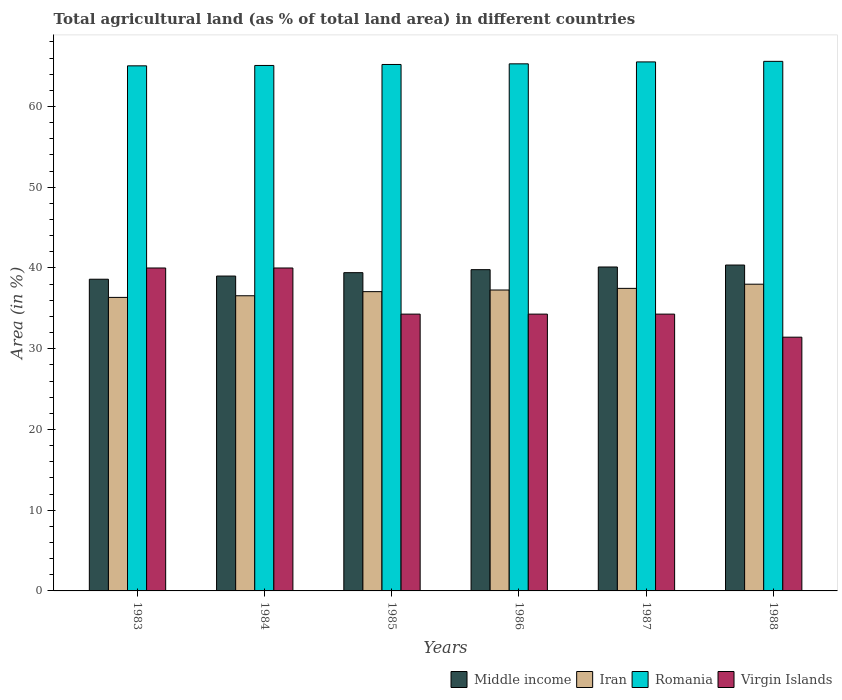How many different coloured bars are there?
Provide a succinct answer. 4. How many groups of bars are there?
Offer a terse response. 6. Are the number of bars per tick equal to the number of legend labels?
Provide a short and direct response. Yes. How many bars are there on the 3rd tick from the left?
Offer a terse response. 4. What is the percentage of agricultural land in Middle income in 1988?
Keep it short and to the point. 40.36. Across all years, what is the minimum percentage of agricultural land in Middle income?
Make the answer very short. 38.61. What is the total percentage of agricultural land in Romania in the graph?
Your response must be concise. 391.74. What is the difference between the percentage of agricultural land in Middle income in 1985 and that in 1986?
Your answer should be very brief. -0.37. What is the difference between the percentage of agricultural land in Iran in 1987 and the percentage of agricultural land in Virgin Islands in 1983?
Keep it short and to the point. -2.52. What is the average percentage of agricultural land in Middle income per year?
Provide a succinct answer. 39.55. In the year 1984, what is the difference between the percentage of agricultural land in Virgin Islands and percentage of agricultural land in Iran?
Provide a short and direct response. 3.44. What is the ratio of the percentage of agricultural land in Middle income in 1985 to that in 1986?
Your answer should be compact. 0.99. Is the difference between the percentage of agricultural land in Virgin Islands in 1987 and 1988 greater than the difference between the percentage of agricultural land in Iran in 1987 and 1988?
Provide a short and direct response. Yes. What is the difference between the highest and the second highest percentage of agricultural land in Middle income?
Provide a short and direct response. 0.24. What is the difference between the highest and the lowest percentage of agricultural land in Romania?
Make the answer very short. 0.56. In how many years, is the percentage of agricultural land in Iran greater than the average percentage of agricultural land in Iran taken over all years?
Ensure brevity in your answer.  3. Is the sum of the percentage of agricultural land in Virgin Islands in 1985 and 1986 greater than the maximum percentage of agricultural land in Iran across all years?
Make the answer very short. Yes. Is it the case that in every year, the sum of the percentage of agricultural land in Virgin Islands and percentage of agricultural land in Romania is greater than the sum of percentage of agricultural land in Iran and percentage of agricultural land in Middle income?
Offer a very short reply. Yes. What does the 1st bar from the right in 1985 represents?
Your answer should be compact. Virgin Islands. How many bars are there?
Ensure brevity in your answer.  24. How many years are there in the graph?
Make the answer very short. 6. What is the difference between two consecutive major ticks on the Y-axis?
Keep it short and to the point. 10. Does the graph contain grids?
Offer a very short reply. No. What is the title of the graph?
Offer a terse response. Total agricultural land (as % of total land area) in different countries. Does "Argentina" appear as one of the legend labels in the graph?
Your answer should be very brief. No. What is the label or title of the Y-axis?
Your answer should be compact. Area (in %). What is the Area (in %) in Middle income in 1983?
Provide a short and direct response. 38.61. What is the Area (in %) in Iran in 1983?
Your response must be concise. 36.36. What is the Area (in %) in Romania in 1983?
Keep it short and to the point. 65.04. What is the Area (in %) of Virgin Islands in 1983?
Offer a very short reply. 40. What is the Area (in %) of Middle income in 1984?
Give a very brief answer. 39. What is the Area (in %) of Iran in 1984?
Give a very brief answer. 36.56. What is the Area (in %) of Romania in 1984?
Provide a short and direct response. 65.09. What is the Area (in %) of Virgin Islands in 1984?
Provide a short and direct response. 40. What is the Area (in %) of Middle income in 1985?
Your answer should be compact. 39.42. What is the Area (in %) in Iran in 1985?
Provide a short and direct response. 37.07. What is the Area (in %) in Romania in 1985?
Keep it short and to the point. 65.21. What is the Area (in %) of Virgin Islands in 1985?
Keep it short and to the point. 34.29. What is the Area (in %) in Middle income in 1986?
Provide a short and direct response. 39.79. What is the Area (in %) in Iran in 1986?
Make the answer very short. 37.27. What is the Area (in %) of Romania in 1986?
Offer a terse response. 65.29. What is the Area (in %) of Virgin Islands in 1986?
Your answer should be very brief. 34.29. What is the Area (in %) of Middle income in 1987?
Provide a succinct answer. 40.12. What is the Area (in %) of Iran in 1987?
Offer a very short reply. 37.48. What is the Area (in %) in Romania in 1987?
Provide a succinct answer. 65.52. What is the Area (in %) in Virgin Islands in 1987?
Ensure brevity in your answer.  34.29. What is the Area (in %) of Middle income in 1988?
Keep it short and to the point. 40.36. What is the Area (in %) of Iran in 1988?
Your response must be concise. 37.99. What is the Area (in %) in Romania in 1988?
Your answer should be compact. 65.59. What is the Area (in %) in Virgin Islands in 1988?
Your answer should be very brief. 31.43. Across all years, what is the maximum Area (in %) in Middle income?
Make the answer very short. 40.36. Across all years, what is the maximum Area (in %) in Iran?
Offer a very short reply. 37.99. Across all years, what is the maximum Area (in %) in Romania?
Provide a succinct answer. 65.59. Across all years, what is the maximum Area (in %) in Virgin Islands?
Keep it short and to the point. 40. Across all years, what is the minimum Area (in %) of Middle income?
Offer a very short reply. 38.61. Across all years, what is the minimum Area (in %) in Iran?
Provide a succinct answer. 36.36. Across all years, what is the minimum Area (in %) of Romania?
Your answer should be compact. 65.04. Across all years, what is the minimum Area (in %) of Virgin Islands?
Keep it short and to the point. 31.43. What is the total Area (in %) of Middle income in the graph?
Offer a terse response. 237.31. What is the total Area (in %) of Iran in the graph?
Give a very brief answer. 222.73. What is the total Area (in %) in Romania in the graph?
Provide a short and direct response. 391.74. What is the total Area (in %) in Virgin Islands in the graph?
Provide a short and direct response. 214.29. What is the difference between the Area (in %) in Middle income in 1983 and that in 1984?
Keep it short and to the point. -0.39. What is the difference between the Area (in %) of Iran in 1983 and that in 1984?
Keep it short and to the point. -0.2. What is the difference between the Area (in %) in Romania in 1983 and that in 1984?
Give a very brief answer. -0.05. What is the difference between the Area (in %) of Virgin Islands in 1983 and that in 1984?
Give a very brief answer. 0. What is the difference between the Area (in %) in Middle income in 1983 and that in 1985?
Your answer should be compact. -0.81. What is the difference between the Area (in %) of Iran in 1983 and that in 1985?
Your answer should be compact. -0.71. What is the difference between the Area (in %) of Romania in 1983 and that in 1985?
Make the answer very short. -0.17. What is the difference between the Area (in %) of Virgin Islands in 1983 and that in 1985?
Ensure brevity in your answer.  5.71. What is the difference between the Area (in %) of Middle income in 1983 and that in 1986?
Your answer should be very brief. -1.18. What is the difference between the Area (in %) of Iran in 1983 and that in 1986?
Provide a short and direct response. -0.91. What is the difference between the Area (in %) in Romania in 1983 and that in 1986?
Provide a short and direct response. -0.25. What is the difference between the Area (in %) in Virgin Islands in 1983 and that in 1986?
Your answer should be compact. 5.71. What is the difference between the Area (in %) in Middle income in 1983 and that in 1987?
Your answer should be compact. -1.51. What is the difference between the Area (in %) of Iran in 1983 and that in 1987?
Make the answer very short. -1.12. What is the difference between the Area (in %) of Romania in 1983 and that in 1987?
Offer a terse response. -0.49. What is the difference between the Area (in %) of Virgin Islands in 1983 and that in 1987?
Offer a very short reply. 5.71. What is the difference between the Area (in %) in Middle income in 1983 and that in 1988?
Offer a terse response. -1.76. What is the difference between the Area (in %) of Iran in 1983 and that in 1988?
Ensure brevity in your answer.  -1.63. What is the difference between the Area (in %) of Romania in 1983 and that in 1988?
Ensure brevity in your answer.  -0.56. What is the difference between the Area (in %) in Virgin Islands in 1983 and that in 1988?
Make the answer very short. 8.57. What is the difference between the Area (in %) in Middle income in 1984 and that in 1985?
Your answer should be very brief. -0.42. What is the difference between the Area (in %) in Iran in 1984 and that in 1985?
Ensure brevity in your answer.  -0.51. What is the difference between the Area (in %) in Romania in 1984 and that in 1985?
Your response must be concise. -0.12. What is the difference between the Area (in %) in Virgin Islands in 1984 and that in 1985?
Ensure brevity in your answer.  5.71. What is the difference between the Area (in %) in Middle income in 1984 and that in 1986?
Provide a short and direct response. -0.79. What is the difference between the Area (in %) of Iran in 1984 and that in 1986?
Give a very brief answer. -0.71. What is the difference between the Area (in %) of Romania in 1984 and that in 1986?
Keep it short and to the point. -0.2. What is the difference between the Area (in %) of Virgin Islands in 1984 and that in 1986?
Ensure brevity in your answer.  5.71. What is the difference between the Area (in %) of Middle income in 1984 and that in 1987?
Your answer should be compact. -1.12. What is the difference between the Area (in %) in Iran in 1984 and that in 1987?
Your answer should be very brief. -0.91. What is the difference between the Area (in %) of Romania in 1984 and that in 1987?
Your response must be concise. -0.44. What is the difference between the Area (in %) of Virgin Islands in 1984 and that in 1987?
Your response must be concise. 5.71. What is the difference between the Area (in %) in Middle income in 1984 and that in 1988?
Offer a very short reply. -1.36. What is the difference between the Area (in %) of Iran in 1984 and that in 1988?
Offer a terse response. -1.43. What is the difference between the Area (in %) of Romania in 1984 and that in 1988?
Your answer should be compact. -0.51. What is the difference between the Area (in %) of Virgin Islands in 1984 and that in 1988?
Keep it short and to the point. 8.57. What is the difference between the Area (in %) of Middle income in 1985 and that in 1986?
Offer a very short reply. -0.37. What is the difference between the Area (in %) in Iran in 1985 and that in 1986?
Your answer should be compact. -0.2. What is the difference between the Area (in %) in Romania in 1985 and that in 1986?
Your response must be concise. -0.08. What is the difference between the Area (in %) in Middle income in 1985 and that in 1987?
Make the answer very short. -0.7. What is the difference between the Area (in %) of Iran in 1985 and that in 1987?
Offer a terse response. -0.41. What is the difference between the Area (in %) of Romania in 1985 and that in 1987?
Your answer should be compact. -0.32. What is the difference between the Area (in %) of Virgin Islands in 1985 and that in 1987?
Provide a succinct answer. 0. What is the difference between the Area (in %) in Middle income in 1985 and that in 1988?
Offer a very short reply. -0.94. What is the difference between the Area (in %) in Iran in 1985 and that in 1988?
Keep it short and to the point. -0.92. What is the difference between the Area (in %) in Romania in 1985 and that in 1988?
Your answer should be compact. -0.39. What is the difference between the Area (in %) of Virgin Islands in 1985 and that in 1988?
Provide a short and direct response. 2.86. What is the difference between the Area (in %) in Middle income in 1986 and that in 1987?
Your answer should be compact. -0.33. What is the difference between the Area (in %) of Iran in 1986 and that in 1987?
Your response must be concise. -0.2. What is the difference between the Area (in %) in Romania in 1986 and that in 1987?
Your response must be concise. -0.24. What is the difference between the Area (in %) of Middle income in 1986 and that in 1988?
Give a very brief answer. -0.57. What is the difference between the Area (in %) in Iran in 1986 and that in 1988?
Give a very brief answer. -0.72. What is the difference between the Area (in %) of Romania in 1986 and that in 1988?
Offer a terse response. -0.31. What is the difference between the Area (in %) of Virgin Islands in 1986 and that in 1988?
Your answer should be very brief. 2.86. What is the difference between the Area (in %) of Middle income in 1987 and that in 1988?
Your response must be concise. -0.24. What is the difference between the Area (in %) in Iran in 1987 and that in 1988?
Keep it short and to the point. -0.52. What is the difference between the Area (in %) of Romania in 1987 and that in 1988?
Offer a terse response. -0.07. What is the difference between the Area (in %) of Virgin Islands in 1987 and that in 1988?
Offer a very short reply. 2.86. What is the difference between the Area (in %) in Middle income in 1983 and the Area (in %) in Iran in 1984?
Your answer should be very brief. 2.05. What is the difference between the Area (in %) of Middle income in 1983 and the Area (in %) of Romania in 1984?
Offer a very short reply. -26.48. What is the difference between the Area (in %) of Middle income in 1983 and the Area (in %) of Virgin Islands in 1984?
Your answer should be compact. -1.39. What is the difference between the Area (in %) in Iran in 1983 and the Area (in %) in Romania in 1984?
Your response must be concise. -28.73. What is the difference between the Area (in %) of Iran in 1983 and the Area (in %) of Virgin Islands in 1984?
Your answer should be very brief. -3.64. What is the difference between the Area (in %) in Romania in 1983 and the Area (in %) in Virgin Islands in 1984?
Provide a short and direct response. 25.04. What is the difference between the Area (in %) of Middle income in 1983 and the Area (in %) of Iran in 1985?
Your answer should be compact. 1.54. What is the difference between the Area (in %) of Middle income in 1983 and the Area (in %) of Romania in 1985?
Your answer should be compact. -26.6. What is the difference between the Area (in %) of Middle income in 1983 and the Area (in %) of Virgin Islands in 1985?
Your answer should be very brief. 4.32. What is the difference between the Area (in %) in Iran in 1983 and the Area (in %) in Romania in 1985?
Give a very brief answer. -28.85. What is the difference between the Area (in %) of Iran in 1983 and the Area (in %) of Virgin Islands in 1985?
Make the answer very short. 2.07. What is the difference between the Area (in %) in Romania in 1983 and the Area (in %) in Virgin Islands in 1985?
Give a very brief answer. 30.75. What is the difference between the Area (in %) in Middle income in 1983 and the Area (in %) in Iran in 1986?
Your response must be concise. 1.34. What is the difference between the Area (in %) in Middle income in 1983 and the Area (in %) in Romania in 1986?
Your answer should be very brief. -26.68. What is the difference between the Area (in %) of Middle income in 1983 and the Area (in %) of Virgin Islands in 1986?
Make the answer very short. 4.32. What is the difference between the Area (in %) in Iran in 1983 and the Area (in %) in Romania in 1986?
Your response must be concise. -28.93. What is the difference between the Area (in %) in Iran in 1983 and the Area (in %) in Virgin Islands in 1986?
Your answer should be compact. 2.07. What is the difference between the Area (in %) of Romania in 1983 and the Area (in %) of Virgin Islands in 1986?
Your response must be concise. 30.75. What is the difference between the Area (in %) of Middle income in 1983 and the Area (in %) of Iran in 1987?
Provide a succinct answer. 1.13. What is the difference between the Area (in %) of Middle income in 1983 and the Area (in %) of Romania in 1987?
Your answer should be very brief. -26.92. What is the difference between the Area (in %) of Middle income in 1983 and the Area (in %) of Virgin Islands in 1987?
Your response must be concise. 4.32. What is the difference between the Area (in %) in Iran in 1983 and the Area (in %) in Romania in 1987?
Provide a short and direct response. -29.17. What is the difference between the Area (in %) of Iran in 1983 and the Area (in %) of Virgin Islands in 1987?
Make the answer very short. 2.07. What is the difference between the Area (in %) of Romania in 1983 and the Area (in %) of Virgin Islands in 1987?
Offer a terse response. 30.75. What is the difference between the Area (in %) in Middle income in 1983 and the Area (in %) in Iran in 1988?
Ensure brevity in your answer.  0.62. What is the difference between the Area (in %) of Middle income in 1983 and the Area (in %) of Romania in 1988?
Your answer should be compact. -26.99. What is the difference between the Area (in %) in Middle income in 1983 and the Area (in %) in Virgin Islands in 1988?
Your answer should be very brief. 7.18. What is the difference between the Area (in %) in Iran in 1983 and the Area (in %) in Romania in 1988?
Provide a short and direct response. -29.24. What is the difference between the Area (in %) in Iran in 1983 and the Area (in %) in Virgin Islands in 1988?
Keep it short and to the point. 4.93. What is the difference between the Area (in %) in Romania in 1983 and the Area (in %) in Virgin Islands in 1988?
Keep it short and to the point. 33.61. What is the difference between the Area (in %) in Middle income in 1984 and the Area (in %) in Iran in 1985?
Provide a succinct answer. 1.93. What is the difference between the Area (in %) in Middle income in 1984 and the Area (in %) in Romania in 1985?
Provide a short and direct response. -26.21. What is the difference between the Area (in %) of Middle income in 1984 and the Area (in %) of Virgin Islands in 1985?
Your answer should be very brief. 4.71. What is the difference between the Area (in %) of Iran in 1984 and the Area (in %) of Romania in 1985?
Your answer should be compact. -28.65. What is the difference between the Area (in %) in Iran in 1984 and the Area (in %) in Virgin Islands in 1985?
Your response must be concise. 2.27. What is the difference between the Area (in %) of Romania in 1984 and the Area (in %) of Virgin Islands in 1985?
Give a very brief answer. 30.8. What is the difference between the Area (in %) of Middle income in 1984 and the Area (in %) of Iran in 1986?
Give a very brief answer. 1.73. What is the difference between the Area (in %) in Middle income in 1984 and the Area (in %) in Romania in 1986?
Your response must be concise. -26.29. What is the difference between the Area (in %) of Middle income in 1984 and the Area (in %) of Virgin Islands in 1986?
Keep it short and to the point. 4.71. What is the difference between the Area (in %) of Iran in 1984 and the Area (in %) of Romania in 1986?
Keep it short and to the point. -28.73. What is the difference between the Area (in %) of Iran in 1984 and the Area (in %) of Virgin Islands in 1986?
Provide a succinct answer. 2.27. What is the difference between the Area (in %) of Romania in 1984 and the Area (in %) of Virgin Islands in 1986?
Provide a succinct answer. 30.8. What is the difference between the Area (in %) in Middle income in 1984 and the Area (in %) in Iran in 1987?
Make the answer very short. 1.52. What is the difference between the Area (in %) of Middle income in 1984 and the Area (in %) of Romania in 1987?
Give a very brief answer. -26.53. What is the difference between the Area (in %) in Middle income in 1984 and the Area (in %) in Virgin Islands in 1987?
Provide a succinct answer. 4.71. What is the difference between the Area (in %) in Iran in 1984 and the Area (in %) in Romania in 1987?
Make the answer very short. -28.96. What is the difference between the Area (in %) in Iran in 1984 and the Area (in %) in Virgin Islands in 1987?
Ensure brevity in your answer.  2.27. What is the difference between the Area (in %) in Romania in 1984 and the Area (in %) in Virgin Islands in 1987?
Offer a terse response. 30.8. What is the difference between the Area (in %) of Middle income in 1984 and the Area (in %) of Iran in 1988?
Ensure brevity in your answer.  1.01. What is the difference between the Area (in %) of Middle income in 1984 and the Area (in %) of Romania in 1988?
Your answer should be very brief. -26.59. What is the difference between the Area (in %) in Middle income in 1984 and the Area (in %) in Virgin Islands in 1988?
Your answer should be very brief. 7.57. What is the difference between the Area (in %) of Iran in 1984 and the Area (in %) of Romania in 1988?
Keep it short and to the point. -29.03. What is the difference between the Area (in %) of Iran in 1984 and the Area (in %) of Virgin Islands in 1988?
Your answer should be compact. 5.13. What is the difference between the Area (in %) in Romania in 1984 and the Area (in %) in Virgin Islands in 1988?
Make the answer very short. 33.66. What is the difference between the Area (in %) in Middle income in 1985 and the Area (in %) in Iran in 1986?
Make the answer very short. 2.15. What is the difference between the Area (in %) of Middle income in 1985 and the Area (in %) of Romania in 1986?
Ensure brevity in your answer.  -25.87. What is the difference between the Area (in %) of Middle income in 1985 and the Area (in %) of Virgin Islands in 1986?
Keep it short and to the point. 5.13. What is the difference between the Area (in %) in Iran in 1985 and the Area (in %) in Romania in 1986?
Your answer should be compact. -28.22. What is the difference between the Area (in %) in Iran in 1985 and the Area (in %) in Virgin Islands in 1986?
Your answer should be very brief. 2.78. What is the difference between the Area (in %) of Romania in 1985 and the Area (in %) of Virgin Islands in 1986?
Offer a very short reply. 30.92. What is the difference between the Area (in %) in Middle income in 1985 and the Area (in %) in Iran in 1987?
Offer a very short reply. 1.94. What is the difference between the Area (in %) in Middle income in 1985 and the Area (in %) in Romania in 1987?
Your answer should be very brief. -26.11. What is the difference between the Area (in %) of Middle income in 1985 and the Area (in %) of Virgin Islands in 1987?
Provide a short and direct response. 5.13. What is the difference between the Area (in %) in Iran in 1985 and the Area (in %) in Romania in 1987?
Your answer should be very brief. -28.46. What is the difference between the Area (in %) in Iran in 1985 and the Area (in %) in Virgin Islands in 1987?
Offer a very short reply. 2.78. What is the difference between the Area (in %) of Romania in 1985 and the Area (in %) of Virgin Islands in 1987?
Keep it short and to the point. 30.92. What is the difference between the Area (in %) of Middle income in 1985 and the Area (in %) of Iran in 1988?
Make the answer very short. 1.43. What is the difference between the Area (in %) in Middle income in 1985 and the Area (in %) in Romania in 1988?
Your answer should be compact. -26.17. What is the difference between the Area (in %) of Middle income in 1985 and the Area (in %) of Virgin Islands in 1988?
Your answer should be compact. 7.99. What is the difference between the Area (in %) in Iran in 1985 and the Area (in %) in Romania in 1988?
Offer a terse response. -28.52. What is the difference between the Area (in %) in Iran in 1985 and the Area (in %) in Virgin Islands in 1988?
Provide a short and direct response. 5.64. What is the difference between the Area (in %) of Romania in 1985 and the Area (in %) of Virgin Islands in 1988?
Your answer should be compact. 33.78. What is the difference between the Area (in %) in Middle income in 1986 and the Area (in %) in Iran in 1987?
Provide a succinct answer. 2.32. What is the difference between the Area (in %) in Middle income in 1986 and the Area (in %) in Romania in 1987?
Ensure brevity in your answer.  -25.73. What is the difference between the Area (in %) of Middle income in 1986 and the Area (in %) of Virgin Islands in 1987?
Offer a terse response. 5.51. What is the difference between the Area (in %) in Iran in 1986 and the Area (in %) in Romania in 1987?
Provide a short and direct response. -28.25. What is the difference between the Area (in %) of Iran in 1986 and the Area (in %) of Virgin Islands in 1987?
Provide a short and direct response. 2.99. What is the difference between the Area (in %) in Romania in 1986 and the Area (in %) in Virgin Islands in 1987?
Your response must be concise. 31. What is the difference between the Area (in %) of Middle income in 1986 and the Area (in %) of Iran in 1988?
Your response must be concise. 1.8. What is the difference between the Area (in %) in Middle income in 1986 and the Area (in %) in Romania in 1988?
Ensure brevity in your answer.  -25.8. What is the difference between the Area (in %) of Middle income in 1986 and the Area (in %) of Virgin Islands in 1988?
Give a very brief answer. 8.36. What is the difference between the Area (in %) of Iran in 1986 and the Area (in %) of Romania in 1988?
Your answer should be very brief. -28.32. What is the difference between the Area (in %) in Iran in 1986 and the Area (in %) in Virgin Islands in 1988?
Ensure brevity in your answer.  5.84. What is the difference between the Area (in %) of Romania in 1986 and the Area (in %) of Virgin Islands in 1988?
Offer a terse response. 33.86. What is the difference between the Area (in %) of Middle income in 1987 and the Area (in %) of Iran in 1988?
Offer a very short reply. 2.13. What is the difference between the Area (in %) of Middle income in 1987 and the Area (in %) of Romania in 1988?
Your answer should be compact. -25.47. What is the difference between the Area (in %) of Middle income in 1987 and the Area (in %) of Virgin Islands in 1988?
Ensure brevity in your answer.  8.69. What is the difference between the Area (in %) of Iran in 1987 and the Area (in %) of Romania in 1988?
Provide a succinct answer. -28.12. What is the difference between the Area (in %) in Iran in 1987 and the Area (in %) in Virgin Islands in 1988?
Your answer should be compact. 6.05. What is the difference between the Area (in %) in Romania in 1987 and the Area (in %) in Virgin Islands in 1988?
Offer a very short reply. 34.1. What is the average Area (in %) in Middle income per year?
Keep it short and to the point. 39.55. What is the average Area (in %) of Iran per year?
Make the answer very short. 37.12. What is the average Area (in %) of Romania per year?
Ensure brevity in your answer.  65.29. What is the average Area (in %) in Virgin Islands per year?
Provide a succinct answer. 35.71. In the year 1983, what is the difference between the Area (in %) in Middle income and Area (in %) in Iran?
Offer a very short reply. 2.25. In the year 1983, what is the difference between the Area (in %) in Middle income and Area (in %) in Romania?
Your answer should be compact. -26.43. In the year 1983, what is the difference between the Area (in %) of Middle income and Area (in %) of Virgin Islands?
Your response must be concise. -1.39. In the year 1983, what is the difference between the Area (in %) in Iran and Area (in %) in Romania?
Your answer should be compact. -28.68. In the year 1983, what is the difference between the Area (in %) in Iran and Area (in %) in Virgin Islands?
Ensure brevity in your answer.  -3.64. In the year 1983, what is the difference between the Area (in %) of Romania and Area (in %) of Virgin Islands?
Keep it short and to the point. 25.04. In the year 1984, what is the difference between the Area (in %) in Middle income and Area (in %) in Iran?
Provide a short and direct response. 2.44. In the year 1984, what is the difference between the Area (in %) of Middle income and Area (in %) of Romania?
Ensure brevity in your answer.  -26.09. In the year 1984, what is the difference between the Area (in %) of Middle income and Area (in %) of Virgin Islands?
Your answer should be compact. -1. In the year 1984, what is the difference between the Area (in %) in Iran and Area (in %) in Romania?
Your response must be concise. -28.53. In the year 1984, what is the difference between the Area (in %) of Iran and Area (in %) of Virgin Islands?
Give a very brief answer. -3.44. In the year 1984, what is the difference between the Area (in %) in Romania and Area (in %) in Virgin Islands?
Your answer should be very brief. 25.09. In the year 1985, what is the difference between the Area (in %) of Middle income and Area (in %) of Iran?
Your answer should be compact. 2.35. In the year 1985, what is the difference between the Area (in %) of Middle income and Area (in %) of Romania?
Offer a very short reply. -25.79. In the year 1985, what is the difference between the Area (in %) of Middle income and Area (in %) of Virgin Islands?
Provide a short and direct response. 5.13. In the year 1985, what is the difference between the Area (in %) in Iran and Area (in %) in Romania?
Provide a short and direct response. -28.14. In the year 1985, what is the difference between the Area (in %) in Iran and Area (in %) in Virgin Islands?
Make the answer very short. 2.78. In the year 1985, what is the difference between the Area (in %) of Romania and Area (in %) of Virgin Islands?
Provide a short and direct response. 30.92. In the year 1986, what is the difference between the Area (in %) in Middle income and Area (in %) in Iran?
Your answer should be very brief. 2.52. In the year 1986, what is the difference between the Area (in %) in Middle income and Area (in %) in Romania?
Provide a succinct answer. -25.49. In the year 1986, what is the difference between the Area (in %) in Middle income and Area (in %) in Virgin Islands?
Give a very brief answer. 5.51. In the year 1986, what is the difference between the Area (in %) in Iran and Area (in %) in Romania?
Offer a terse response. -28.01. In the year 1986, what is the difference between the Area (in %) in Iran and Area (in %) in Virgin Islands?
Provide a short and direct response. 2.99. In the year 1986, what is the difference between the Area (in %) in Romania and Area (in %) in Virgin Islands?
Your answer should be very brief. 31. In the year 1987, what is the difference between the Area (in %) of Middle income and Area (in %) of Iran?
Make the answer very short. 2.65. In the year 1987, what is the difference between the Area (in %) in Middle income and Area (in %) in Romania?
Make the answer very short. -25.4. In the year 1987, what is the difference between the Area (in %) in Middle income and Area (in %) in Virgin Islands?
Provide a short and direct response. 5.84. In the year 1987, what is the difference between the Area (in %) of Iran and Area (in %) of Romania?
Keep it short and to the point. -28.05. In the year 1987, what is the difference between the Area (in %) of Iran and Area (in %) of Virgin Islands?
Your answer should be compact. 3.19. In the year 1987, what is the difference between the Area (in %) in Romania and Area (in %) in Virgin Islands?
Your answer should be very brief. 31.24. In the year 1988, what is the difference between the Area (in %) of Middle income and Area (in %) of Iran?
Make the answer very short. 2.37. In the year 1988, what is the difference between the Area (in %) in Middle income and Area (in %) in Romania?
Offer a terse response. -25.23. In the year 1988, what is the difference between the Area (in %) in Middle income and Area (in %) in Virgin Islands?
Provide a short and direct response. 8.94. In the year 1988, what is the difference between the Area (in %) in Iran and Area (in %) in Romania?
Your answer should be very brief. -27.6. In the year 1988, what is the difference between the Area (in %) of Iran and Area (in %) of Virgin Islands?
Ensure brevity in your answer.  6.56. In the year 1988, what is the difference between the Area (in %) in Romania and Area (in %) in Virgin Islands?
Provide a short and direct response. 34.17. What is the ratio of the Area (in %) in Romania in 1983 to that in 1984?
Offer a very short reply. 1. What is the ratio of the Area (in %) of Middle income in 1983 to that in 1985?
Keep it short and to the point. 0.98. What is the ratio of the Area (in %) in Iran in 1983 to that in 1985?
Offer a terse response. 0.98. What is the ratio of the Area (in %) of Virgin Islands in 1983 to that in 1985?
Your response must be concise. 1.17. What is the ratio of the Area (in %) in Middle income in 1983 to that in 1986?
Your answer should be compact. 0.97. What is the ratio of the Area (in %) in Iran in 1983 to that in 1986?
Your response must be concise. 0.98. What is the ratio of the Area (in %) of Virgin Islands in 1983 to that in 1986?
Your answer should be very brief. 1.17. What is the ratio of the Area (in %) of Middle income in 1983 to that in 1987?
Provide a short and direct response. 0.96. What is the ratio of the Area (in %) of Iran in 1983 to that in 1987?
Your response must be concise. 0.97. What is the ratio of the Area (in %) in Romania in 1983 to that in 1987?
Ensure brevity in your answer.  0.99. What is the ratio of the Area (in %) in Virgin Islands in 1983 to that in 1987?
Give a very brief answer. 1.17. What is the ratio of the Area (in %) of Middle income in 1983 to that in 1988?
Your answer should be very brief. 0.96. What is the ratio of the Area (in %) of Romania in 1983 to that in 1988?
Provide a succinct answer. 0.99. What is the ratio of the Area (in %) of Virgin Islands in 1983 to that in 1988?
Offer a very short reply. 1.27. What is the ratio of the Area (in %) of Middle income in 1984 to that in 1985?
Your answer should be compact. 0.99. What is the ratio of the Area (in %) in Iran in 1984 to that in 1985?
Offer a terse response. 0.99. What is the ratio of the Area (in %) of Romania in 1984 to that in 1985?
Make the answer very short. 1. What is the ratio of the Area (in %) of Middle income in 1984 to that in 1986?
Your answer should be compact. 0.98. What is the ratio of the Area (in %) of Iran in 1984 to that in 1986?
Provide a succinct answer. 0.98. What is the ratio of the Area (in %) in Iran in 1984 to that in 1987?
Provide a short and direct response. 0.98. What is the ratio of the Area (in %) in Romania in 1984 to that in 1987?
Your answer should be compact. 0.99. What is the ratio of the Area (in %) of Virgin Islands in 1984 to that in 1987?
Ensure brevity in your answer.  1.17. What is the ratio of the Area (in %) in Middle income in 1984 to that in 1988?
Your answer should be compact. 0.97. What is the ratio of the Area (in %) of Iran in 1984 to that in 1988?
Your answer should be compact. 0.96. What is the ratio of the Area (in %) of Romania in 1984 to that in 1988?
Provide a short and direct response. 0.99. What is the ratio of the Area (in %) in Virgin Islands in 1984 to that in 1988?
Your answer should be very brief. 1.27. What is the ratio of the Area (in %) in Iran in 1985 to that in 1986?
Offer a terse response. 0.99. What is the ratio of the Area (in %) in Romania in 1985 to that in 1986?
Your answer should be very brief. 1. What is the ratio of the Area (in %) in Virgin Islands in 1985 to that in 1986?
Make the answer very short. 1. What is the ratio of the Area (in %) of Middle income in 1985 to that in 1987?
Your answer should be compact. 0.98. What is the ratio of the Area (in %) in Romania in 1985 to that in 1987?
Your answer should be compact. 1. What is the ratio of the Area (in %) in Middle income in 1985 to that in 1988?
Your response must be concise. 0.98. What is the ratio of the Area (in %) in Iran in 1985 to that in 1988?
Your response must be concise. 0.98. What is the ratio of the Area (in %) in Romania in 1985 to that in 1988?
Your answer should be compact. 0.99. What is the ratio of the Area (in %) of Virgin Islands in 1985 to that in 1988?
Provide a short and direct response. 1.09. What is the ratio of the Area (in %) of Middle income in 1986 to that in 1987?
Give a very brief answer. 0.99. What is the ratio of the Area (in %) in Iran in 1986 to that in 1987?
Provide a succinct answer. 0.99. What is the ratio of the Area (in %) of Romania in 1986 to that in 1987?
Offer a terse response. 1. What is the ratio of the Area (in %) in Middle income in 1986 to that in 1988?
Offer a very short reply. 0.99. What is the ratio of the Area (in %) in Iran in 1986 to that in 1988?
Ensure brevity in your answer.  0.98. What is the ratio of the Area (in %) in Middle income in 1987 to that in 1988?
Your response must be concise. 0.99. What is the ratio of the Area (in %) of Iran in 1987 to that in 1988?
Ensure brevity in your answer.  0.99. What is the ratio of the Area (in %) in Romania in 1987 to that in 1988?
Keep it short and to the point. 1. What is the difference between the highest and the second highest Area (in %) in Middle income?
Offer a terse response. 0.24. What is the difference between the highest and the second highest Area (in %) in Iran?
Make the answer very short. 0.52. What is the difference between the highest and the second highest Area (in %) in Romania?
Offer a terse response. 0.07. What is the difference between the highest and the lowest Area (in %) in Middle income?
Your response must be concise. 1.76. What is the difference between the highest and the lowest Area (in %) in Iran?
Provide a succinct answer. 1.63. What is the difference between the highest and the lowest Area (in %) in Romania?
Your response must be concise. 0.56. What is the difference between the highest and the lowest Area (in %) of Virgin Islands?
Provide a succinct answer. 8.57. 